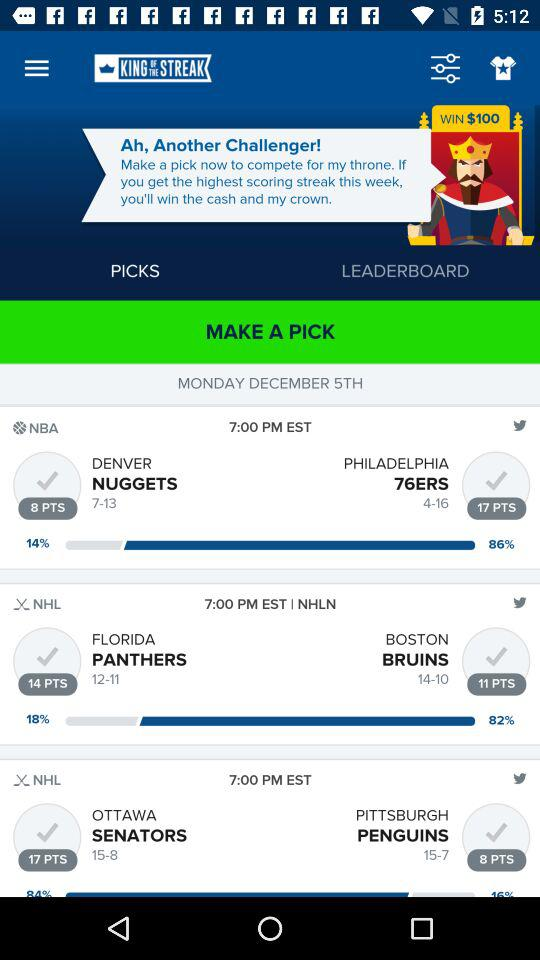What day falls on December 05? The day is Monday. 